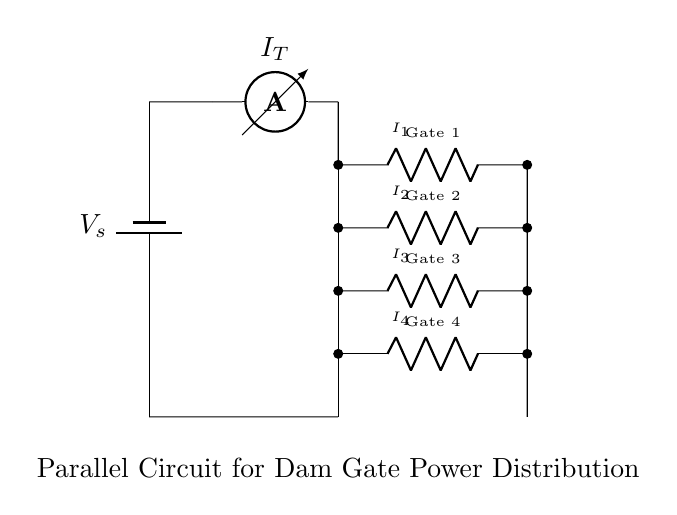What is the total current entering the circuit? The total current entering the circuit is labeled as I_T on the diagram, indicating it is the sum of the currents flowing through all the branches.
Answer: I_T What type of circuit is shown in the diagram? The circuit consists of multiple resistors (Gates 1, 2, 3, and 4) connected in parallel, allowing for a current divider configuration.
Answer: Parallel How many gates are powered in this circuit? The diagram indicates four gates labeled as Gate 1, Gate 2, Gate 3, and Gate 4, thus showing that four gates are powered.
Answer: Four What is the relationship between the currents I_1, I_2, I_3, and I_4? Since this is a current divider circuit, the relationship is described by the equation: I_T = I_1 + I_2 + I_3 + I_4, meaning the total current divides among the gates.
Answer: I_T = I_1 + I_2 + I_3 + I_4 Which gate has the highest current flowing through it? The diagram does not provide specific resistance values, so without additional data, we cannot determine which gate has the highest current. However, it can generally be stated that the gate with the lowest resistance would have the highest current.
Answer: Depends on resistance values 